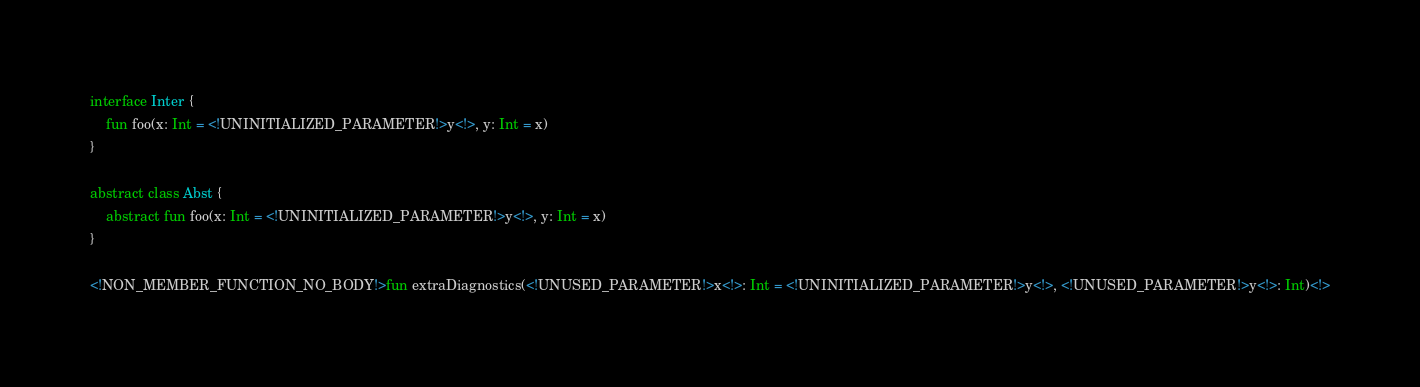Convert code to text. <code><loc_0><loc_0><loc_500><loc_500><_Kotlin_>interface Inter {
    fun foo(x: Int = <!UNINITIALIZED_PARAMETER!>y<!>, y: Int = x)
}

abstract class Abst {
    abstract fun foo(x: Int = <!UNINITIALIZED_PARAMETER!>y<!>, y: Int = x)
}

<!NON_MEMBER_FUNCTION_NO_BODY!>fun extraDiagnostics(<!UNUSED_PARAMETER!>x<!>: Int = <!UNINITIALIZED_PARAMETER!>y<!>, <!UNUSED_PARAMETER!>y<!>: Int)<!></code> 